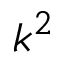<formula> <loc_0><loc_0><loc_500><loc_500>k ^ { 2 }</formula> 